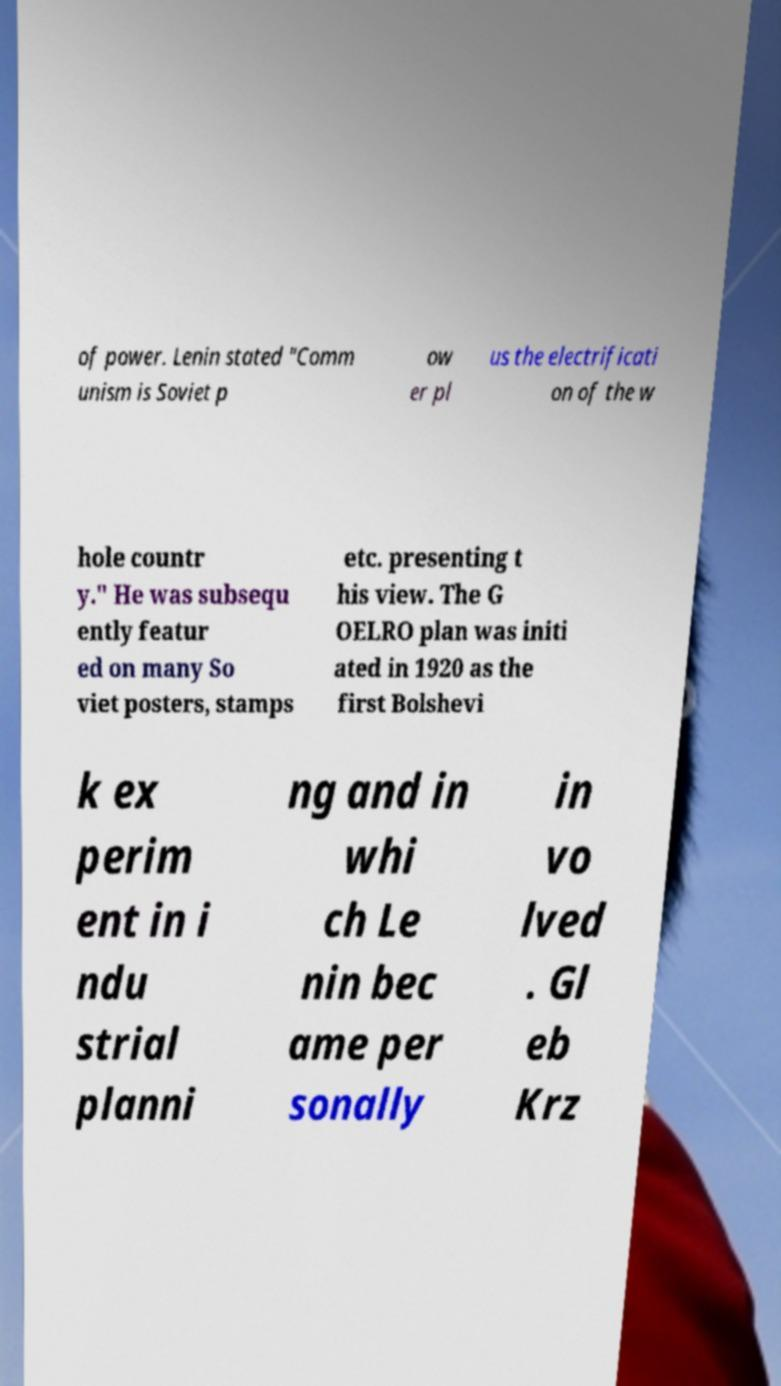For documentation purposes, I need the text within this image transcribed. Could you provide that? of power. Lenin stated "Comm unism is Soviet p ow er pl us the electrificati on of the w hole countr y." He was subsequ ently featur ed on many So viet posters, stamps etc. presenting t his view. The G OELRO plan was initi ated in 1920 as the first Bolshevi k ex perim ent in i ndu strial planni ng and in whi ch Le nin bec ame per sonally in vo lved . Gl eb Krz 